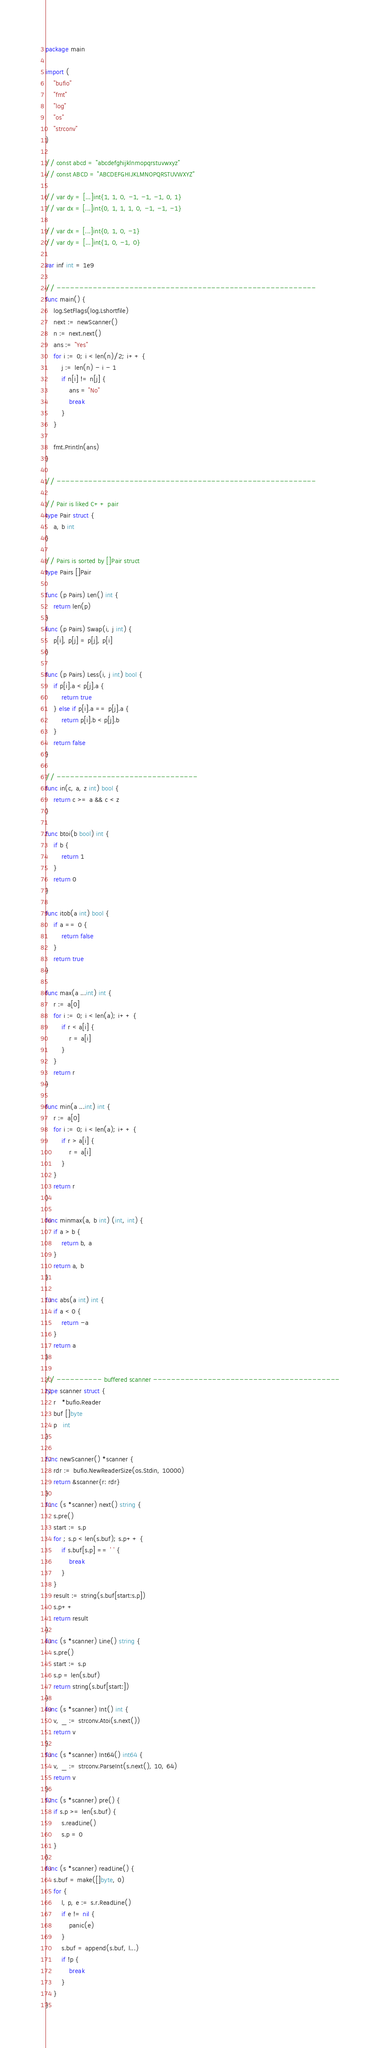<code> <loc_0><loc_0><loc_500><loc_500><_Go_>package main

import (
	"bufio"
	"fmt"
	"log"
	"os"
	"strconv"
)

// const abcd = "abcdefghijklnmopqrstuvwxyz"
// const ABCD = "ABCDEFGHIJKLMNOPQRSTUVWXYZ"

// var dy = [...]int{1, 1, 0, -1, -1, -1, 0, 1}
// var dx = [...]int{0, 1, 1, 1, 0, -1, -1, -1}

// var dx = [...]int{0, 1, 0, -1}
// var dy = [...]int{1, 0, -1, 0}

var inf int = 1e9

// ---------------------------------------------------------
func main() {
	log.SetFlags(log.Lshortfile)
	next := newScanner()
	n := next.next()
	ans := "Yes"
	for i := 0; i < len(n)/2; i++ {
		j := len(n) - i - 1
		if n[i] != n[j] {
			ans = "No"
			break
		}
	}

	fmt.Println(ans)
}

// ---------------------------------------------------------

// Pair is liked C++ pair
type Pair struct {
	a, b int
}

// Pairs is sorted by []Pair struct
type Pairs []Pair

func (p Pairs) Len() int {
	return len(p)
}
func (p Pairs) Swap(i, j int) {
	p[i], p[j] = p[j], p[i]
}

func (p Pairs) Less(i, j int) bool {
	if p[i].a < p[j].a {
		return true
	} else if p[i].a == p[j].a {
		return p[i].b < p[j].b
	}
	return false
}

// -------------------------------
func in(c, a, z int) bool {
	return c >= a && c < z
}

func btoi(b bool) int {
	if b {
		return 1
	}
	return 0
}

func itob(a int) bool {
	if a == 0 {
		return false
	}
	return true
}

func max(a ...int) int {
	r := a[0]
	for i := 0; i < len(a); i++ {
		if r < a[i] {
			r = a[i]
		}
	}
	return r
}

func min(a ...int) int {
	r := a[0]
	for i := 0; i < len(a); i++ {
		if r > a[i] {
			r = a[i]
		}
	}
	return r
}

func minmax(a, b int) (int, int) {
	if a > b {
		return b, a
	}
	return a, b
}

func abs(a int) int {
	if a < 0 {
		return -a
	}
	return a
}

// ---------- buffered scanner -----------------------------------------
type scanner struct {
	r   *bufio.Reader
	buf []byte
	p   int
}

func newScanner() *scanner {
	rdr := bufio.NewReaderSize(os.Stdin, 10000)
	return &scanner{r: rdr}
}
func (s *scanner) next() string {
	s.pre()
	start := s.p
	for ; s.p < len(s.buf); s.p++ {
		if s.buf[s.p] == ' ' {
			break
		}
	}
	result := string(s.buf[start:s.p])
	s.p++
	return result
}
func (s *scanner) Line() string {
	s.pre()
	start := s.p
	s.p = len(s.buf)
	return string(s.buf[start:])
}
func (s *scanner) Int() int {
	v, _ := strconv.Atoi(s.next())
	return v
}
func (s *scanner) Int64() int64 {
	v, _ := strconv.ParseInt(s.next(), 10, 64)
	return v
}
func (s *scanner) pre() {
	if s.p >= len(s.buf) {
		s.readLine()
		s.p = 0
	}
}
func (s *scanner) readLine() {
	s.buf = make([]byte, 0)
	for {
		l, p, e := s.r.ReadLine()
		if e != nil {
			panic(e)
		}
		s.buf = append(s.buf, l...)
		if !p {
			break
		}
	}
}
</code> 